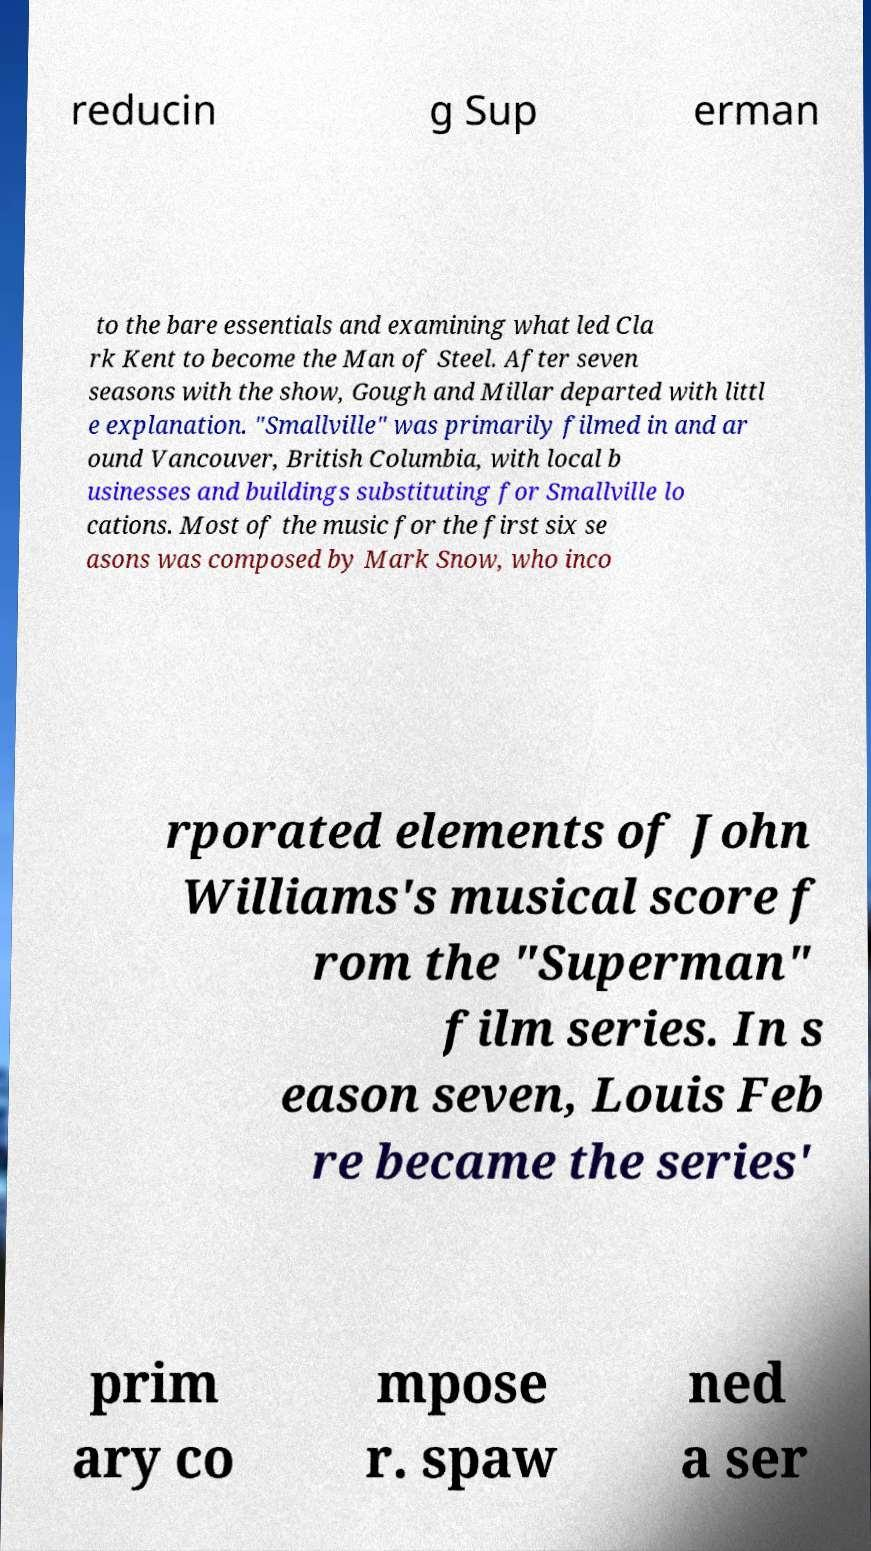For documentation purposes, I need the text within this image transcribed. Could you provide that? reducin g Sup erman to the bare essentials and examining what led Cla rk Kent to become the Man of Steel. After seven seasons with the show, Gough and Millar departed with littl e explanation. "Smallville" was primarily filmed in and ar ound Vancouver, British Columbia, with local b usinesses and buildings substituting for Smallville lo cations. Most of the music for the first six se asons was composed by Mark Snow, who inco rporated elements of John Williams's musical score f rom the "Superman" film series. In s eason seven, Louis Feb re became the series' prim ary co mpose r. spaw ned a ser 